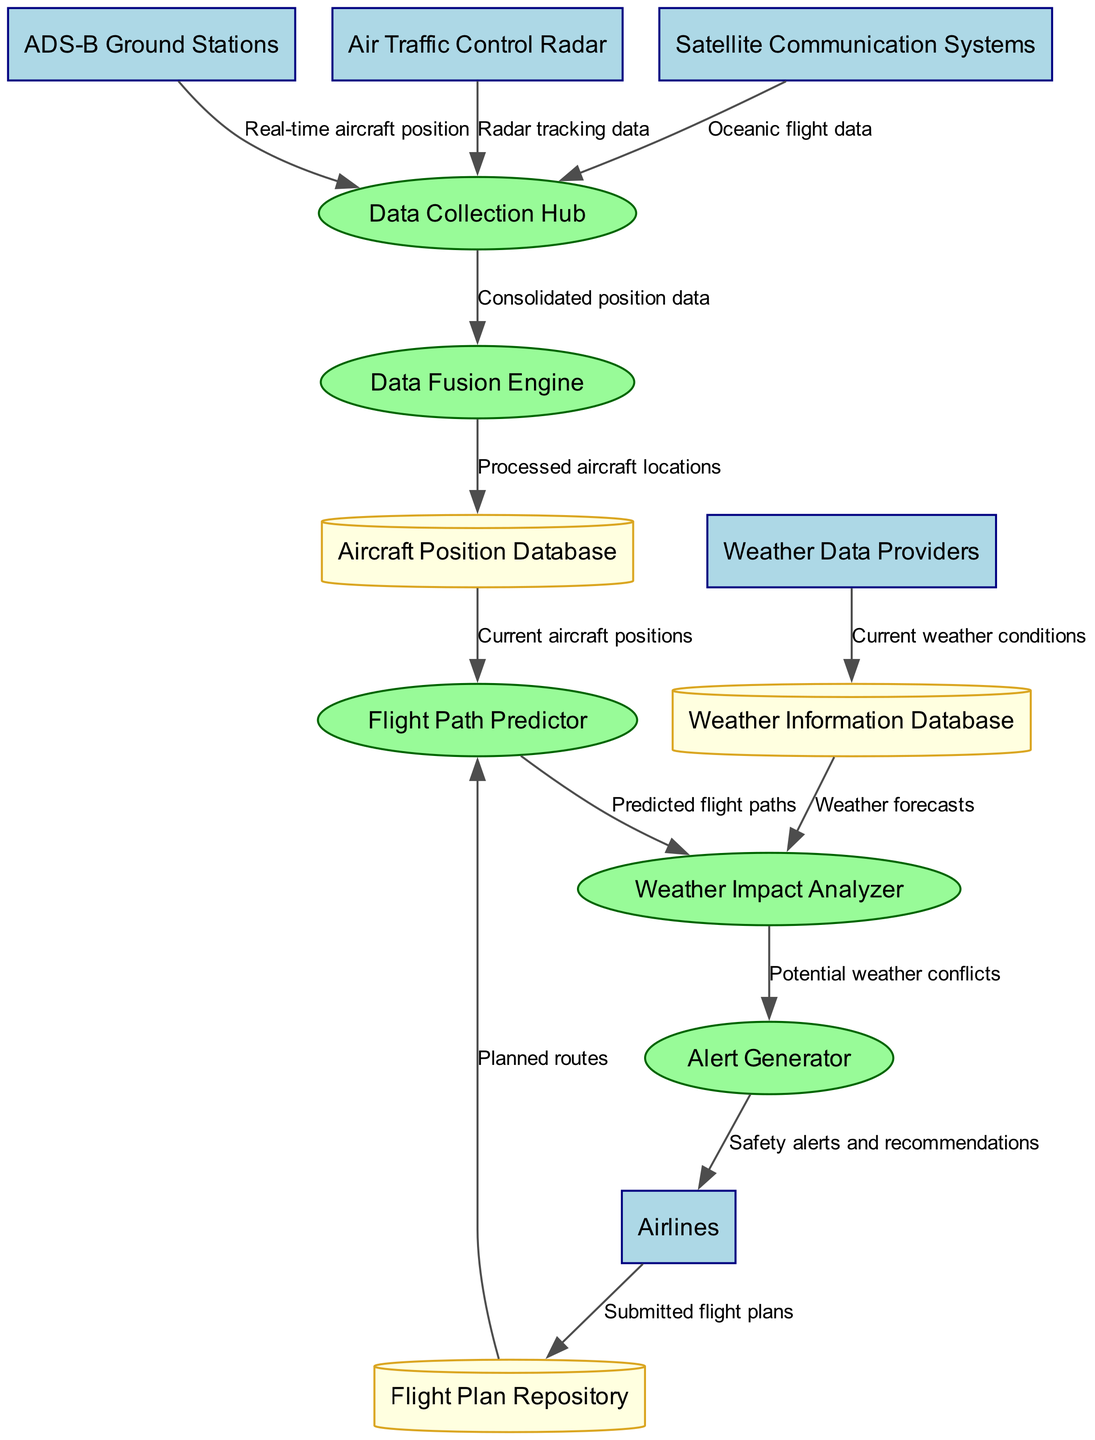What are the external entities involved in the system? The external entities listed in the diagram are ADS-B Ground Stations, Air Traffic Control Radar, Satellite Communication Systems, Weather Data Providers, and Airlines. These are specifically mentioned and serve as data sources or interactions.
Answer: ADS-B Ground Stations, Air Traffic Control Radar, Satellite Communication Systems, Weather Data Providers, Airlines What type of process is the Data Collection Hub? The Data Collection Hub is a process node in the diagram, and specifically, it is categorized as a green ellipse, which signifies a process involved in data handling.
Answer: Process How many data stores are present in the diagram? Upon examining the diagram, there are three data stores: Aircraft Position Database, Flight Plan Repository, and Weather Information Database. Therefore, the total count is three.
Answer: Three What type of data is transferred from Weather Data Providers to Weather Information Database? The data being transferred is described as "Current weather conditions," indicating the type of information being stored regarding weather for subsequent analysis or processing.
Answer: Current weather conditions What is the flow from the Flight Path Predictor to the Weather Impact Analyzer? The data flow from the Flight Path Predictor to the Weather Impact Analyzer is labeled as "Predicted flight paths." This describes the information that is transmitted for further assessment in relation to weather impacts.
Answer: Predicted flight paths Which process generates "Safety alerts and recommendations"? The process that generates "Safety alerts and recommendations" is identified as the Alert Generator, which indicates that it’s responsible for providing alerts based on insights generated from prior processes.
Answer: Alert Generator How does airplane position data enter the Aircraft Position Database? The data flows into the Aircraft Position Database from the Data Fusion Engine, which processes incoming data and consolidates the position data before storing it.
Answer: From Data Fusion Engine What type of information does the Weather Impact Analyzer require for its function? The Weather Impact Analyzer requires "Weather forecasts" from the Weather Information Database as its input to analyze potential impacts on flight paths or operations.
Answer: Weather forecasts Which external entity provides radar tracking data? The external entity providing radar tracking data is specifically the Air Traffic Control Radar, which plays a crucial role in tracking aircraft positions.
Answer: Air Traffic Control Radar 